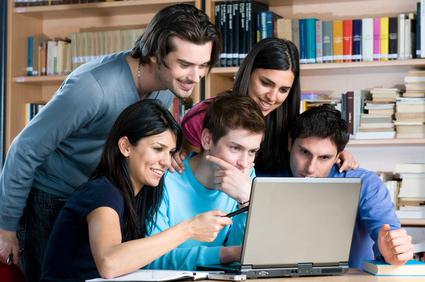Question: why are the people smiling?
Choices:
A. They are watching comedian.
B. They are happy at what they are looking at on the laptop.
C. Someone told a joke.
D. The pizza delivery just arrived.
Answer with the letter. Answer: B Question: who is standing up?
Choices:
A. A man and woman.
B. The horse.
C. A child.
D. A cat.
Answer with the letter. Answer: A Question: where does this picture take place?
Choices:
A. In a library.
B. School.
C. Store.
D. Beach.
Answer with the letter. Answer: A Question: what color are the people's shirts?
Choices:
A. Red,white and blue.
B. Blue, gray and purple.
C. Green, yellow, and white.
D. Orange, blue, and black.
Answer with the letter. Answer: B Question: what are the people looking at?
Choices:
A. A laptop.
B. Movie screen.
C. Cell phone.
D. Window.
Answer with the letter. Answer: A 